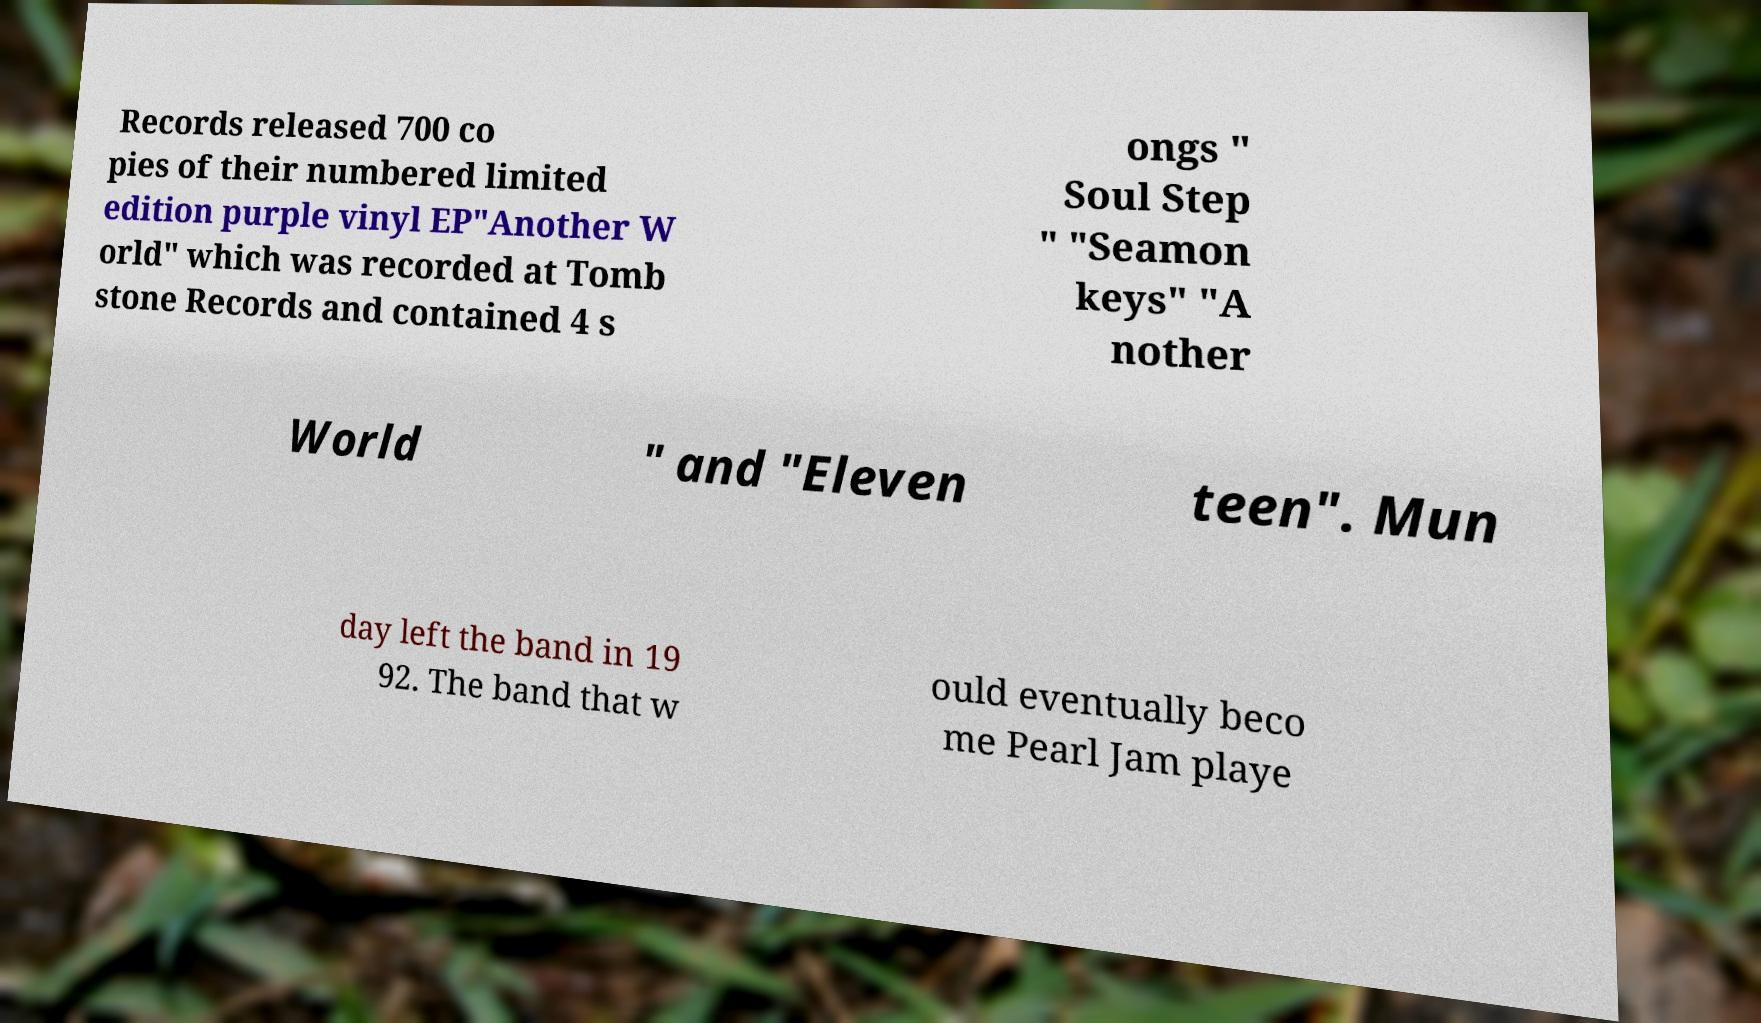Can you read and provide the text displayed in the image?This photo seems to have some interesting text. Can you extract and type it out for me? Records released 700 co pies of their numbered limited edition purple vinyl EP"Another W orld" which was recorded at Tomb stone Records and contained 4 s ongs " Soul Step " "Seamon keys" "A nother World " and "Eleven teen". Mun day left the band in 19 92. The band that w ould eventually beco me Pearl Jam playe 